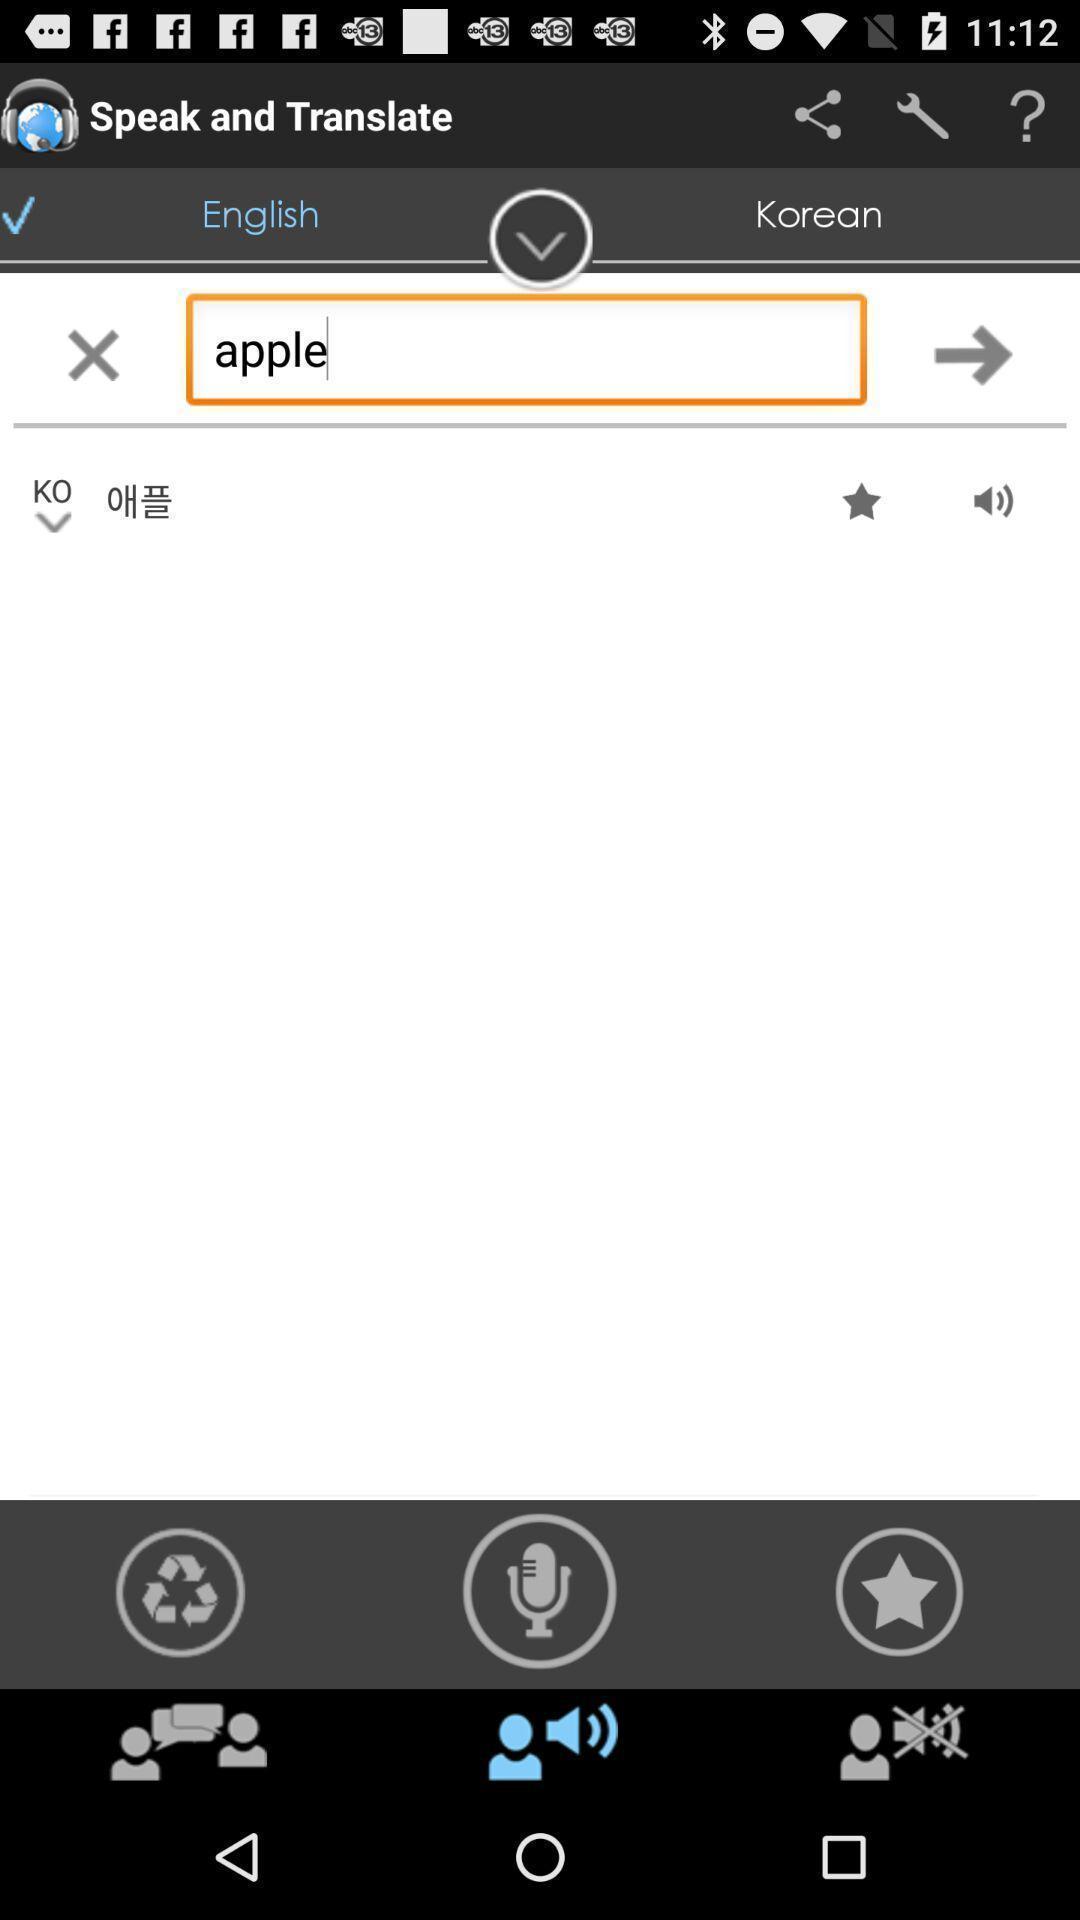Summarize the information in this screenshot. Screen shows different options to translate voice. 